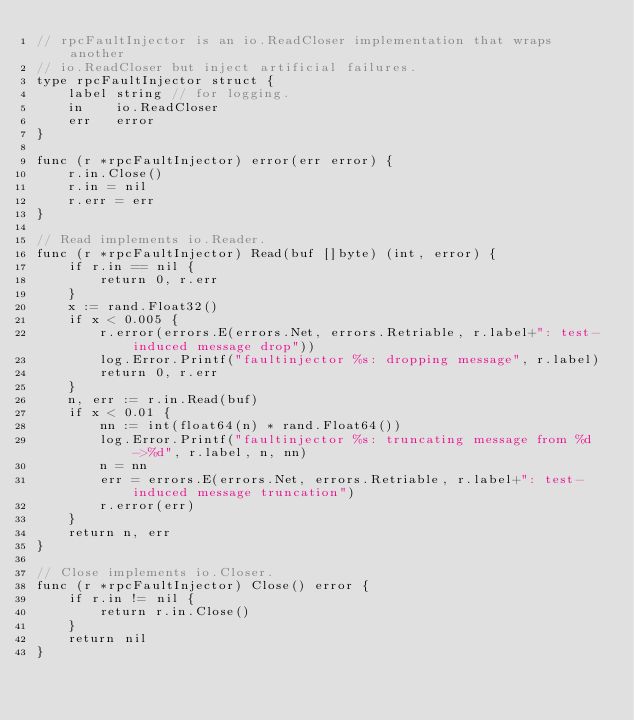Convert code to text. <code><loc_0><loc_0><loc_500><loc_500><_Go_>// rpcFaultInjector is an io.ReadCloser implementation that wraps another
// io.ReadCloser but inject artificial failures.
type rpcFaultInjector struct {
	label string // for logging.
	in    io.ReadCloser
	err   error
}

func (r *rpcFaultInjector) error(err error) {
	r.in.Close()
	r.in = nil
	r.err = err
}

// Read implements io.Reader.
func (r *rpcFaultInjector) Read(buf []byte) (int, error) {
	if r.in == nil {
		return 0, r.err
	}
	x := rand.Float32()
	if x < 0.005 {
		r.error(errors.E(errors.Net, errors.Retriable, r.label+": test-induced message drop"))
		log.Error.Printf("faultinjector %s: dropping message", r.label)
		return 0, r.err
	}
	n, err := r.in.Read(buf)
	if x < 0.01 {
		nn := int(float64(n) * rand.Float64())
		log.Error.Printf("faultinjector %s: truncating message from %d->%d", r.label, n, nn)
		n = nn
		err = errors.E(errors.Net, errors.Retriable, r.label+": test-induced message truncation")
		r.error(err)
	}
	return n, err
}

// Close implements io.Closer.
func (r *rpcFaultInjector) Close() error {
	if r.in != nil {
		return r.in.Close()
	}
	return nil
}
</code> 